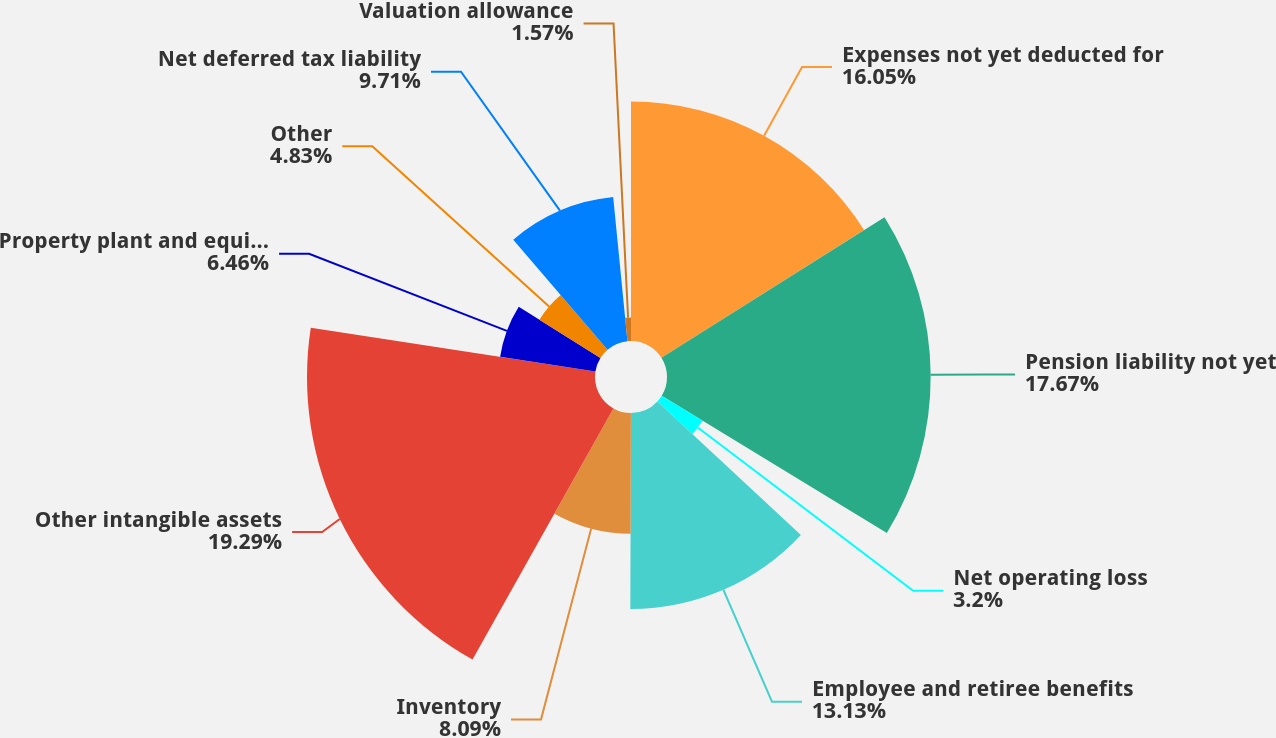<chart> <loc_0><loc_0><loc_500><loc_500><pie_chart><fcel>Expenses not yet deducted for<fcel>Pension liability not yet<fcel>Net operating loss<fcel>Employee and retiree benefits<fcel>Inventory<fcel>Other intangible assets<fcel>Property plant and equipment<fcel>Other<fcel>Net deferred tax liability<fcel>Valuation allowance<nl><fcel>16.05%<fcel>17.67%<fcel>3.2%<fcel>13.13%<fcel>8.09%<fcel>19.3%<fcel>6.46%<fcel>4.83%<fcel>9.71%<fcel>1.57%<nl></chart> 